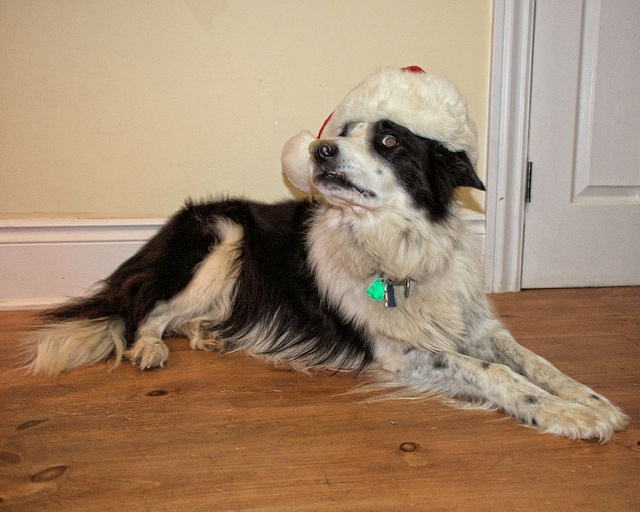Describe the objects in this image and their specific colors. I can see a dog in tan, black, and darkgray tones in this image. 